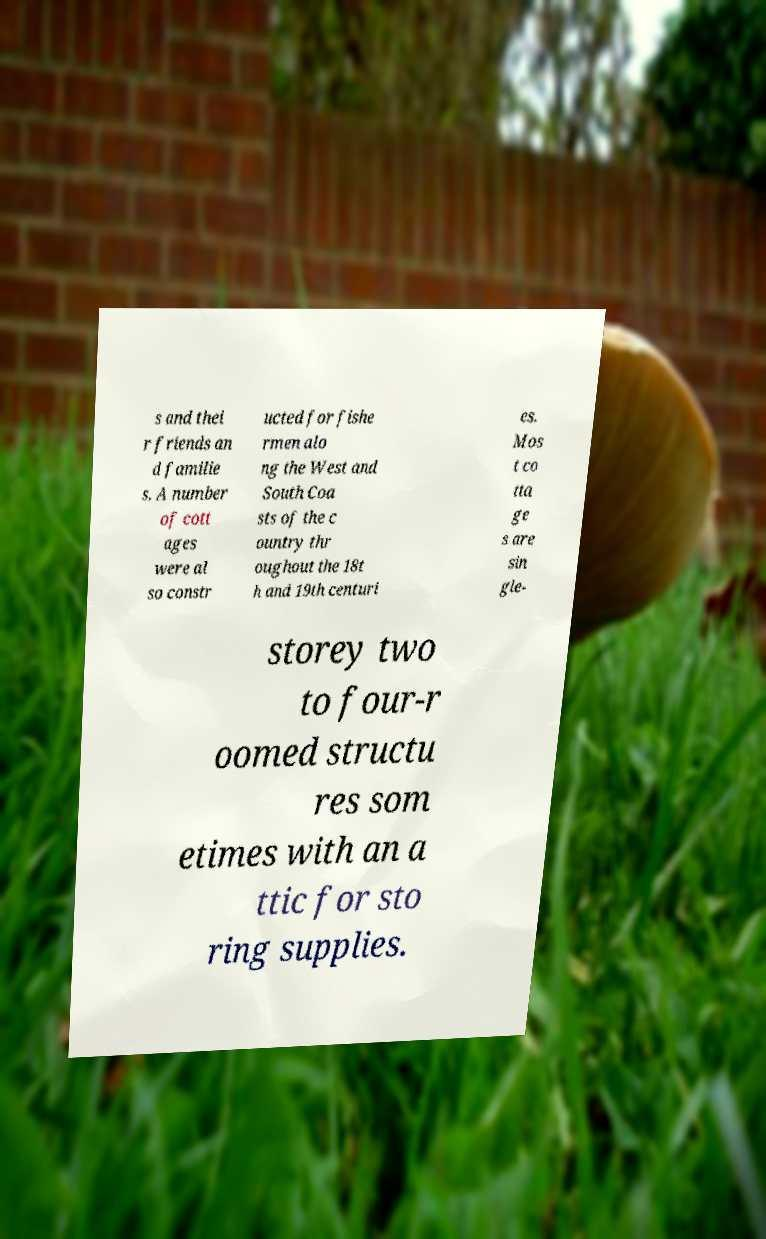Could you extract and type out the text from this image? s and thei r friends an d familie s. A number of cott ages were al so constr ucted for fishe rmen alo ng the West and South Coa sts of the c ountry thr oughout the 18t h and 19th centuri es. Mos t co tta ge s are sin gle- storey two to four-r oomed structu res som etimes with an a ttic for sto ring supplies. 